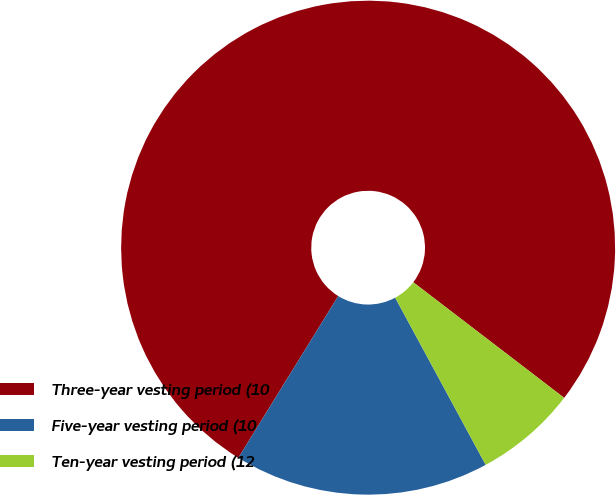Convert chart to OTSL. <chart><loc_0><loc_0><loc_500><loc_500><pie_chart><fcel>Three-year vesting period (10<fcel>Five-year vesting period (10<fcel>Ten-year vesting period (12<nl><fcel>76.6%<fcel>16.7%<fcel>6.7%<nl></chart> 